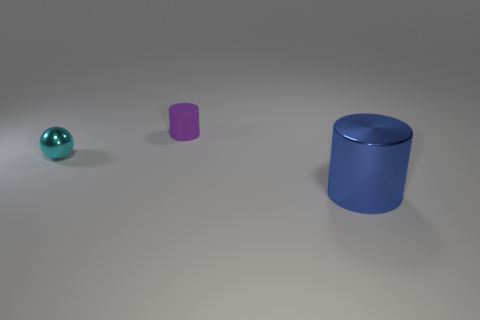Are there any tiny metallic objects behind the small purple cylinder?
Provide a short and direct response. No. Is the material of the small thing in front of the tiny purple cylinder the same as the object behind the cyan metallic object?
Your answer should be compact. No. Are there fewer balls that are right of the cyan object than small yellow rubber cylinders?
Offer a very short reply. No. What color is the metallic object that is on the right side of the tiny metallic ball?
Provide a short and direct response. Blue. There is a cylinder to the left of the object that is to the right of the small purple rubber object; what is its material?
Your response must be concise. Rubber. Is there a blue shiny cylinder of the same size as the blue metallic thing?
Make the answer very short. No. What number of objects are cylinders that are in front of the tiny cyan ball or metallic objects that are on the right side of the small matte cylinder?
Your answer should be compact. 1. There is a shiny thing that is on the right side of the small sphere; is it the same size as the metallic thing to the left of the big metallic cylinder?
Offer a very short reply. No. There is a cylinder in front of the tiny rubber object; are there any small cyan metal things to the right of it?
Your answer should be very brief. No. There is a cyan sphere; how many small purple things are in front of it?
Give a very brief answer. 0. 